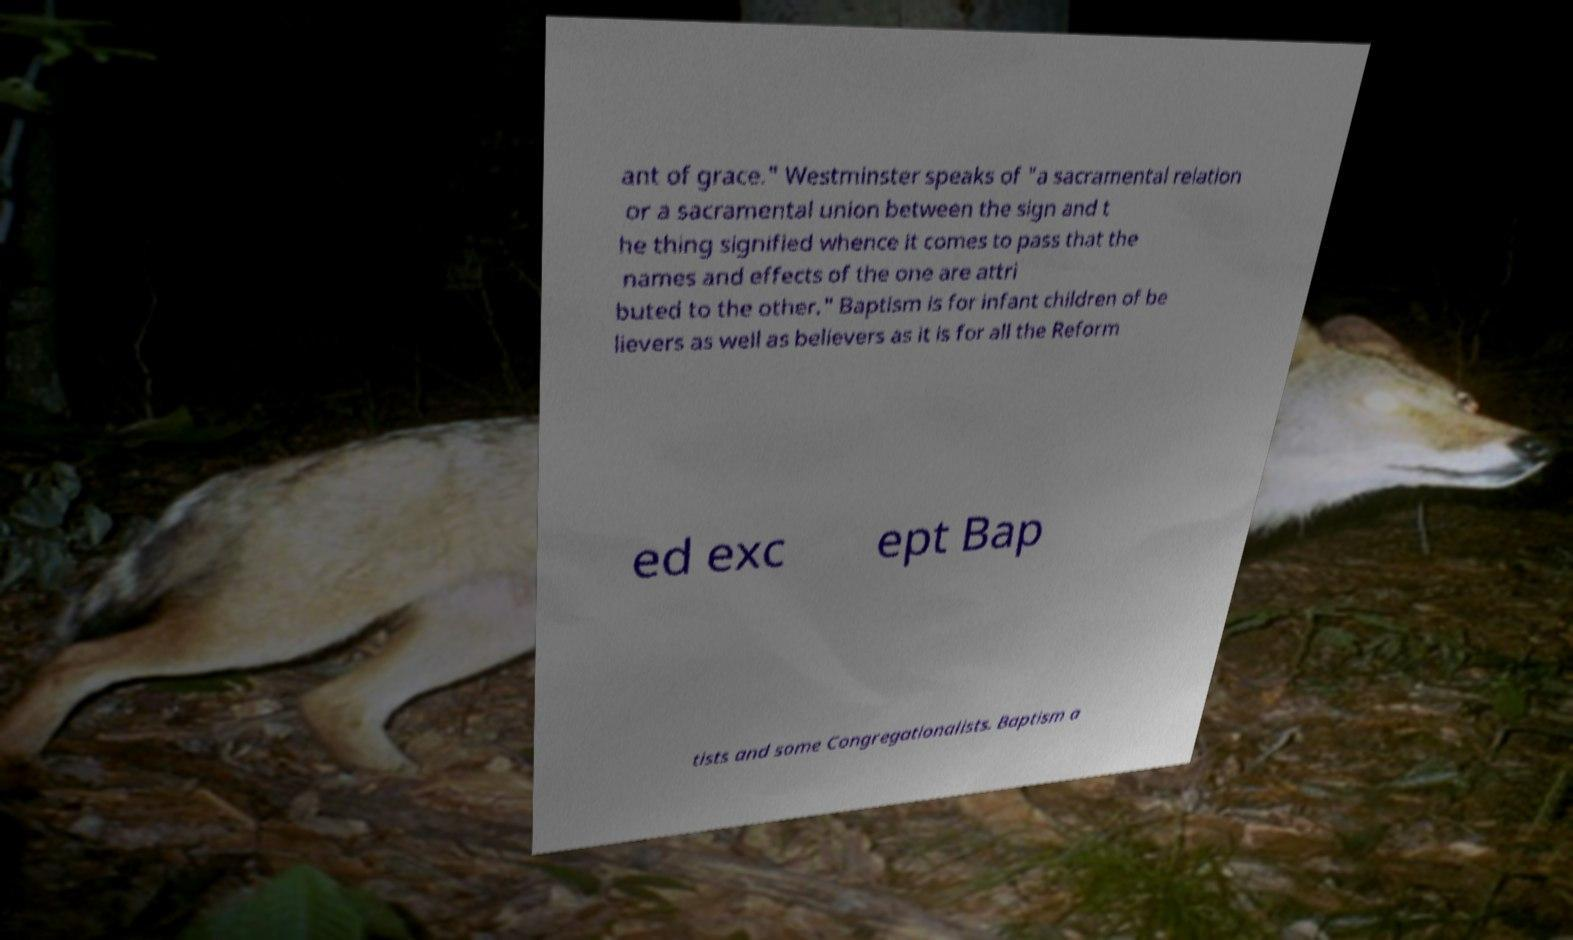Please identify and transcribe the text found in this image. ant of grace." Westminster speaks of "a sacramental relation or a sacramental union between the sign and t he thing signified whence it comes to pass that the names and effects of the one are attri buted to the other." Baptism is for infant children of be lievers as well as believers as it is for all the Reform ed exc ept Bap tists and some Congregationalists. Baptism a 